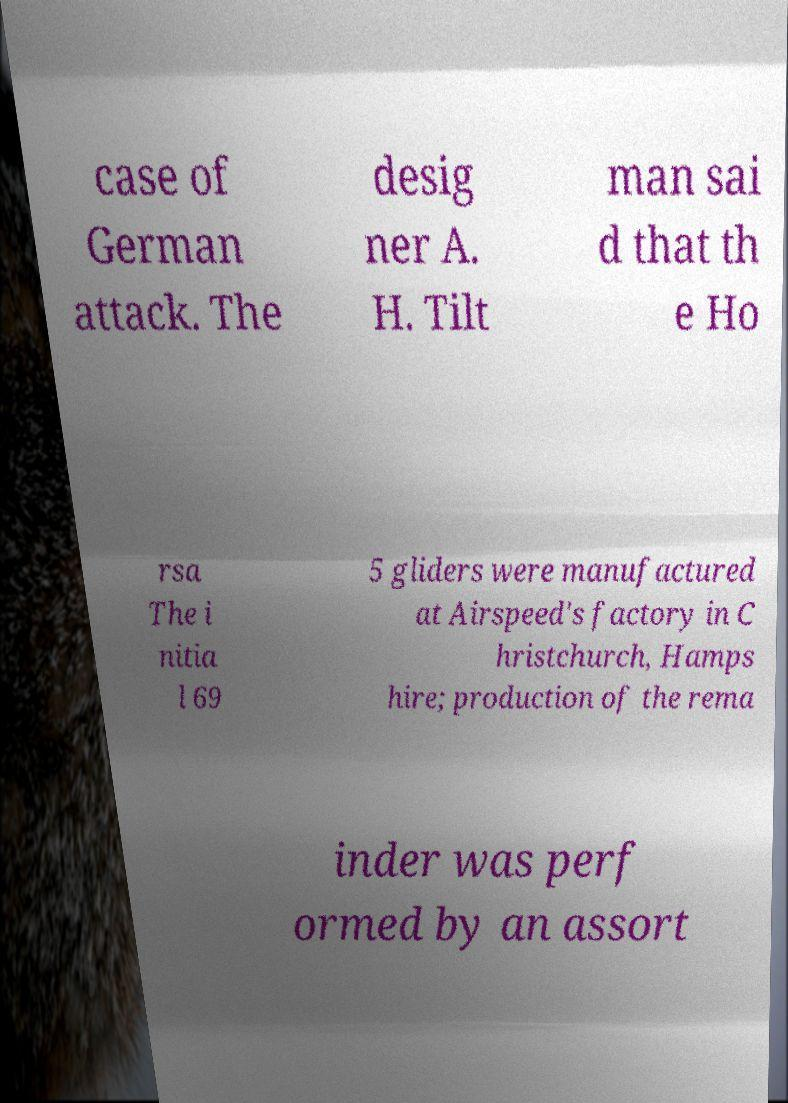There's text embedded in this image that I need extracted. Can you transcribe it verbatim? case of German attack. The desig ner A. H. Tilt man sai d that th e Ho rsa The i nitia l 69 5 gliders were manufactured at Airspeed's factory in C hristchurch, Hamps hire; production of the rema inder was perf ormed by an assort 